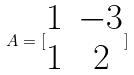<formula> <loc_0><loc_0><loc_500><loc_500>A = [ \begin{matrix} 1 & - 3 \\ 1 & 2 \end{matrix} ]</formula> 